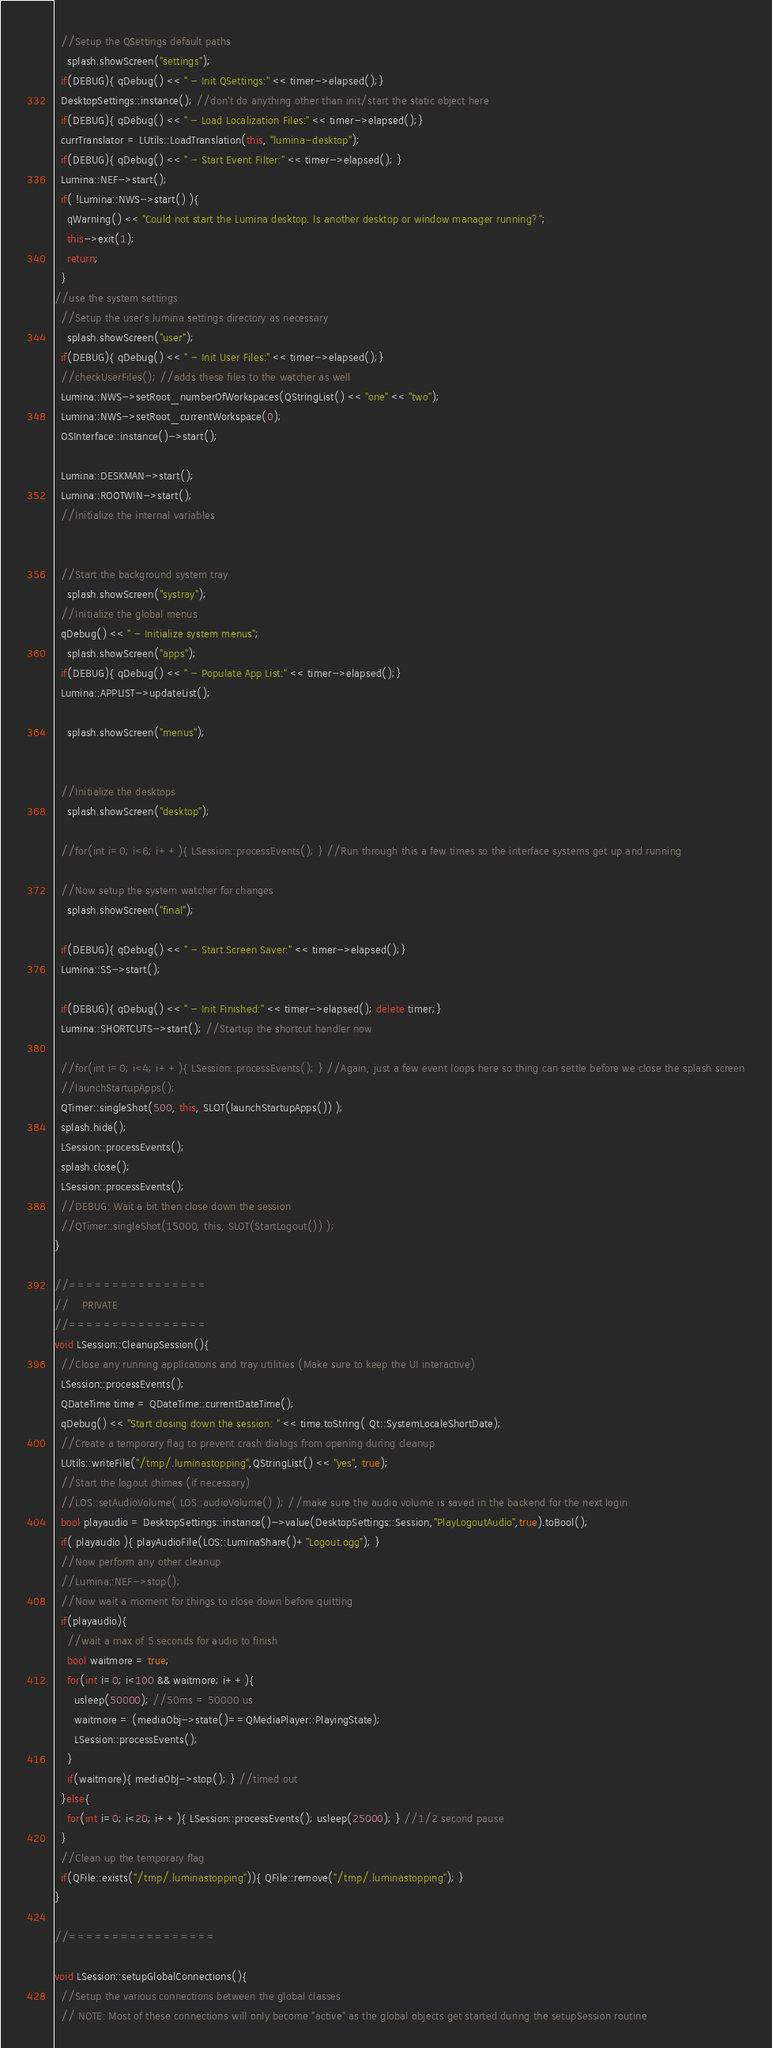<code> <loc_0><loc_0><loc_500><loc_500><_C++_>  //Setup the QSettings default paths
    splash.showScreen("settings");
  if(DEBUG){ qDebug() << " - Init QSettings:" << timer->elapsed();}
  DesktopSettings::instance(); //don't do anything other than init/start the static object here
  if(DEBUG){ qDebug() << " - Load Localization Files:" << timer->elapsed();}
  currTranslator = LUtils::LoadTranslation(this, "lumina-desktop");
  if(DEBUG){ qDebug() << " - Start Event Filter:" << timer->elapsed(); }
  Lumina::NEF->start();
  if( !Lumina::NWS->start() ){
    qWarning() << "Could not start the Lumina desktop. Is another desktop or window manager running?";
    this->exit(1);
    return;
  }
//use the system settings
  //Setup the user's lumina settings directory as necessary
    splash.showScreen("user");
  if(DEBUG){ qDebug() << " - Init User Files:" << timer->elapsed();}
  //checkUserFiles(); //adds these files to the watcher as well
  Lumina::NWS->setRoot_numberOfWorkspaces(QStringList() << "one" << "two");
  Lumina::NWS->setRoot_currentWorkspace(0);
  OSInterface::instance()->start();

  Lumina::DESKMAN->start();
  Lumina::ROOTWIN->start();
  //Initialize the internal variables


  //Start the background system tray
    splash.showScreen("systray");
  //Initialize the global menus
  qDebug() << " - Initialize system menus";
    splash.showScreen("apps");
  if(DEBUG){ qDebug() << " - Populate App List:" << timer->elapsed();}
  Lumina::APPLIST->updateList();

    splash.showScreen("menus");


  //Initialize the desktops
    splash.showScreen("desktop");

  //for(int i=0; i<6; i++){ LSession::processEvents(); } //Run through this a few times so the interface systems get up and running

  //Now setup the system watcher for changes
    splash.showScreen("final");

  if(DEBUG){ qDebug() << " - Start Screen Saver:" << timer->elapsed();}
  Lumina::SS->start();

  if(DEBUG){ qDebug() << " - Init Finished:" << timer->elapsed(); delete timer;}
  Lumina::SHORTCUTS->start(); //Startup the shortcut handler now

  //for(int i=0; i<4; i++){ LSession::processEvents(); } //Again, just a few event loops here so thing can settle before we close the splash screen
  //launchStartupApps();
  QTimer::singleShot(500, this, SLOT(launchStartupApps()) );
  splash.hide();
  LSession::processEvents();
  splash.close();
  LSession::processEvents();
  //DEBUG: Wait a bit then close down the session
  //QTimer::singleShot(15000, this, SLOT(StartLogout()) );
}

//================
//    PRIVATE
//================
void LSession::CleanupSession(){
  //Close any running applications and tray utilities (Make sure to keep the UI interactive)
  LSession::processEvents();
  QDateTime time = QDateTime::currentDateTime();
  qDebug() << "Start closing down the session: " << time.toString( Qt::SystemLocaleShortDate);
  //Create a temporary flag to prevent crash dialogs from opening during cleanup
  LUtils::writeFile("/tmp/.luminastopping",QStringList() << "yes", true);
  //Start the logout chimes (if necessary)
  //LOS::setAudioVolume( LOS::audioVolume() ); //make sure the audio volume is saved in the backend for the next login
  bool playaudio = DesktopSettings::instance()->value(DesktopSettings::Session,"PlayLogoutAudio",true).toBool();
  if( playaudio ){ playAudioFile(LOS::LuminaShare()+"Logout.ogg"); }
  //Now perform any other cleanup
  //Lumina::NEF->stop();
  //Now wait a moment for things to close down before quitting
  if(playaudio){
    //wait a max of 5 seconds for audio to finish
    bool waitmore = true;
    for(int i=0; i<100 && waitmore; i++){
      usleep(50000); //50ms = 50000 us
      waitmore = (mediaObj->state()==QMediaPlayer::PlayingState);
      LSession::processEvents();
    }
    if(waitmore){ mediaObj->stop(); } //timed out
  }else{
    for(int i=0; i<20; i++){ LSession::processEvents(); usleep(25000); } //1/2 second pause
  }
  //Clean up the temporary flag
  if(QFile::exists("/tmp/.luminastopping")){ QFile::remove("/tmp/.luminastopping"); }
}

//=================

void LSession::setupGlobalConnections(){
  //Setup the various connections between the global classes
  // NOTE: Most of these connections will only become "active" as the global objects get started during the setupSession routine
</code> 